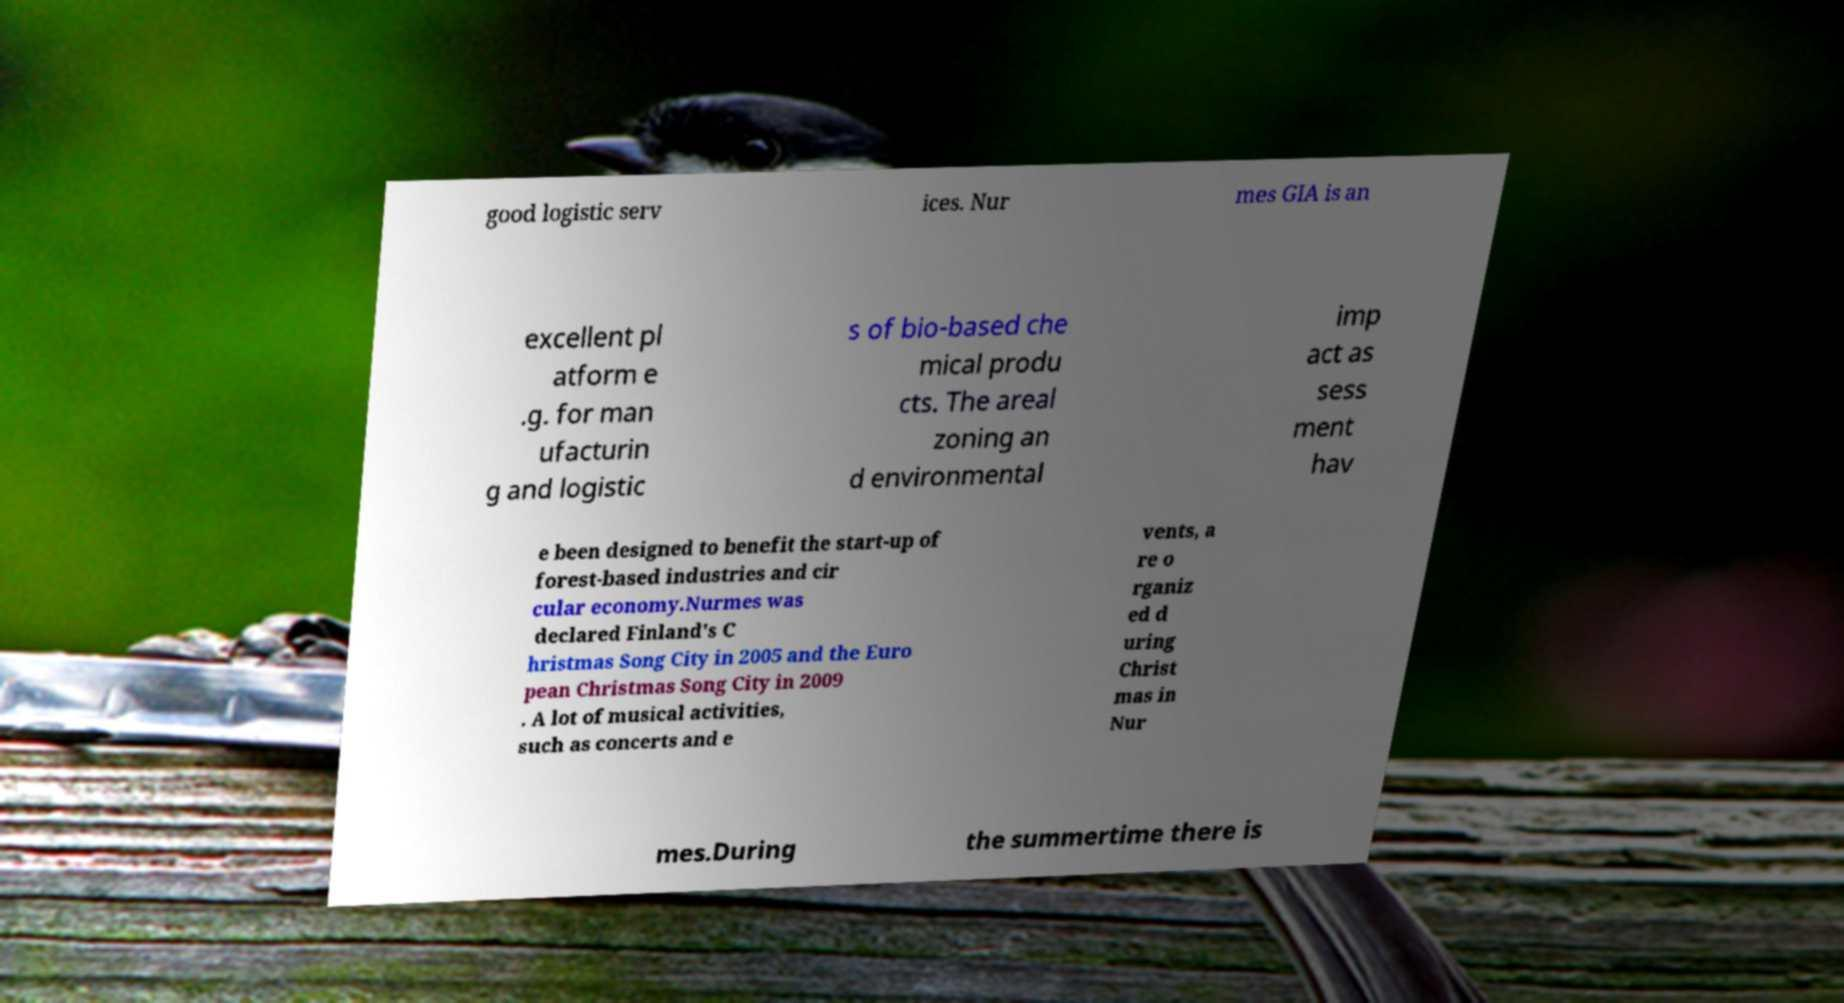Could you extract and type out the text from this image? good logistic serv ices. Nur mes GIA is an excellent pl atform e .g. for man ufacturin g and logistic s of bio-based che mical produ cts. The areal zoning an d environmental imp act as sess ment hav e been designed to benefit the start-up of forest-based industries and cir cular economy.Nurmes was declared Finland's C hristmas Song City in 2005 and the Euro pean Christmas Song City in 2009 . A lot of musical activities, such as concerts and e vents, a re o rganiz ed d uring Christ mas in Nur mes.During the summertime there is 